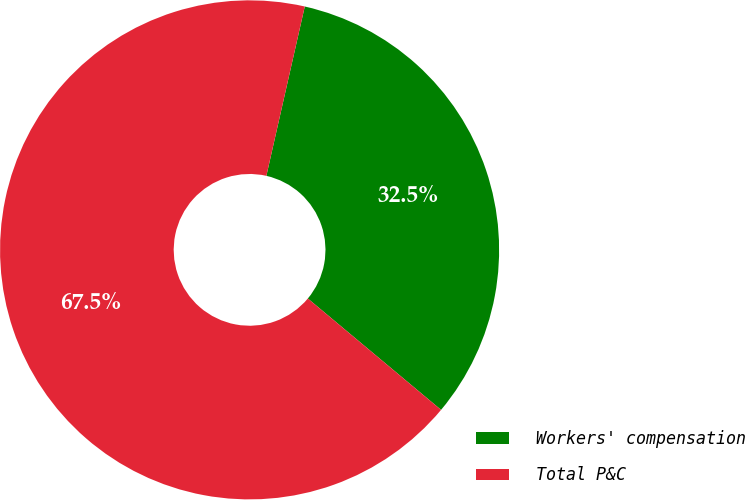Convert chart to OTSL. <chart><loc_0><loc_0><loc_500><loc_500><pie_chart><fcel>Workers' compensation<fcel>Total P&C<nl><fcel>32.53%<fcel>67.47%<nl></chart> 